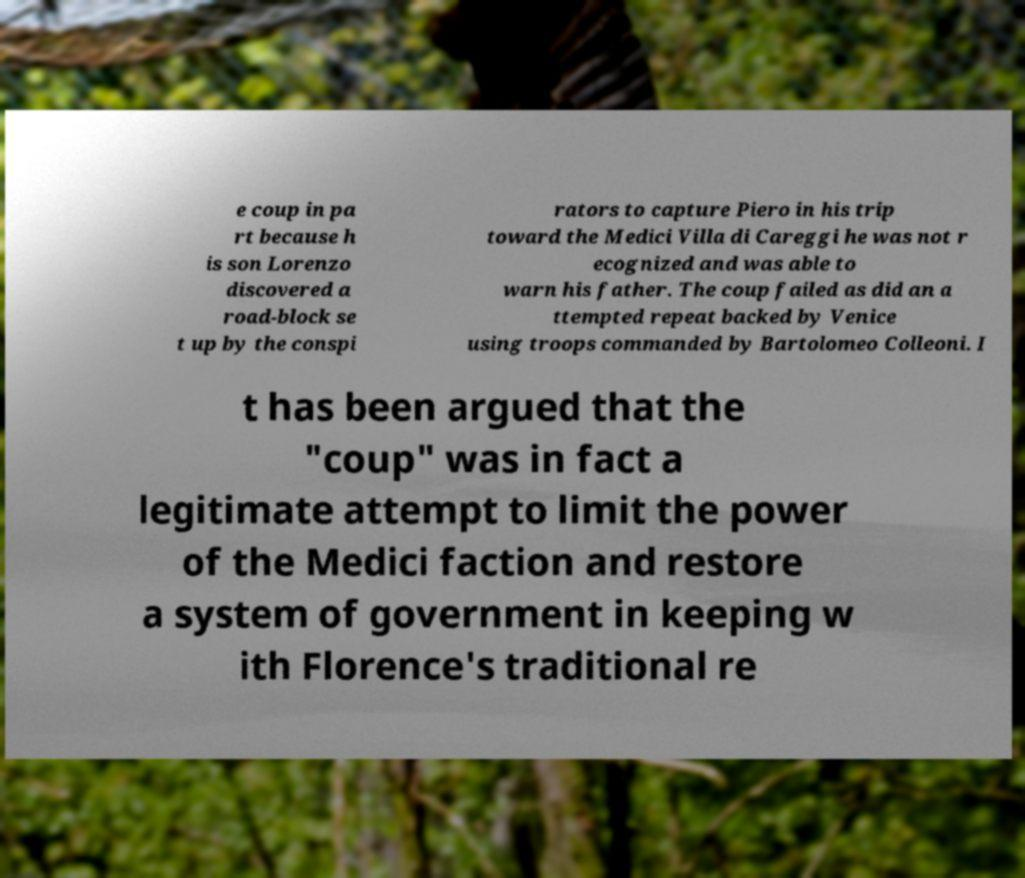Could you assist in decoding the text presented in this image and type it out clearly? e coup in pa rt because h is son Lorenzo discovered a road-block se t up by the conspi rators to capture Piero in his trip toward the Medici Villa di Careggi he was not r ecognized and was able to warn his father. The coup failed as did an a ttempted repeat backed by Venice using troops commanded by Bartolomeo Colleoni. I t has been argued that the "coup" was in fact a legitimate attempt to limit the power of the Medici faction and restore a system of government in keeping w ith Florence's traditional re 